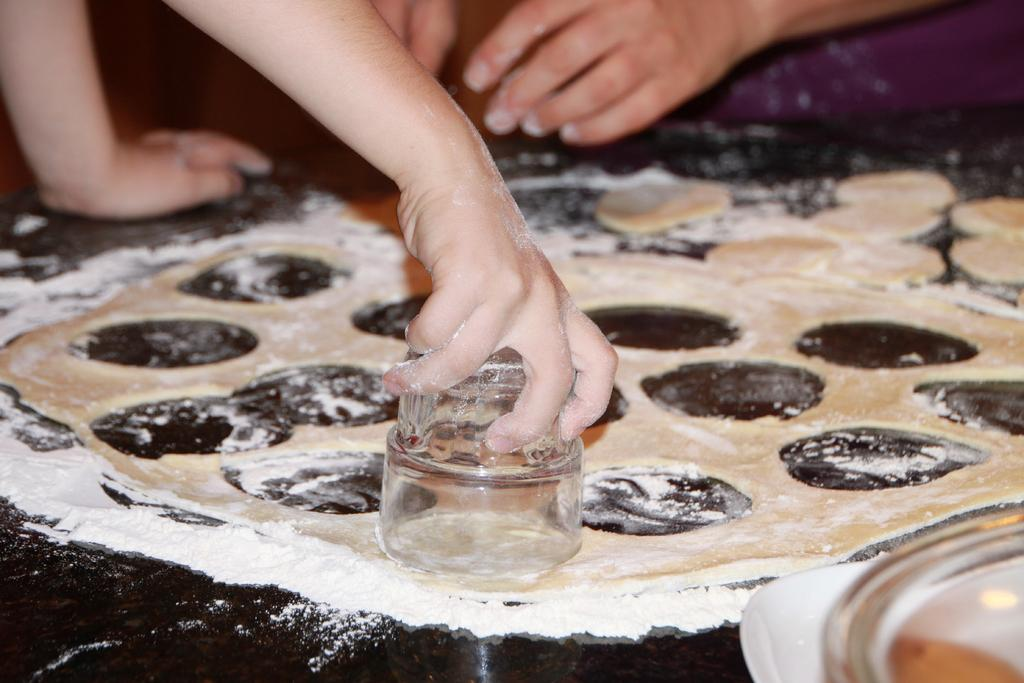What type of food ingredient is present in the image? There is flour in the image. What is being made with the flour in the image? There is batter in the image, which suggests that the flour is being used to make something. What type of container is visible in the image? There is a glass in the image. Who is present in the image? There are people in the image. What object can be used for storage in the image? There is a box in the image. What type of van is parked outside the window in the image? There is no van visible in the image; it only shows flour, batter, a glass, people, and a box. How does the batter compare to the flour in terms of consistency in the image? The image does not provide any information about the consistency of the batter or flour, so it cannot be compared in this way. 